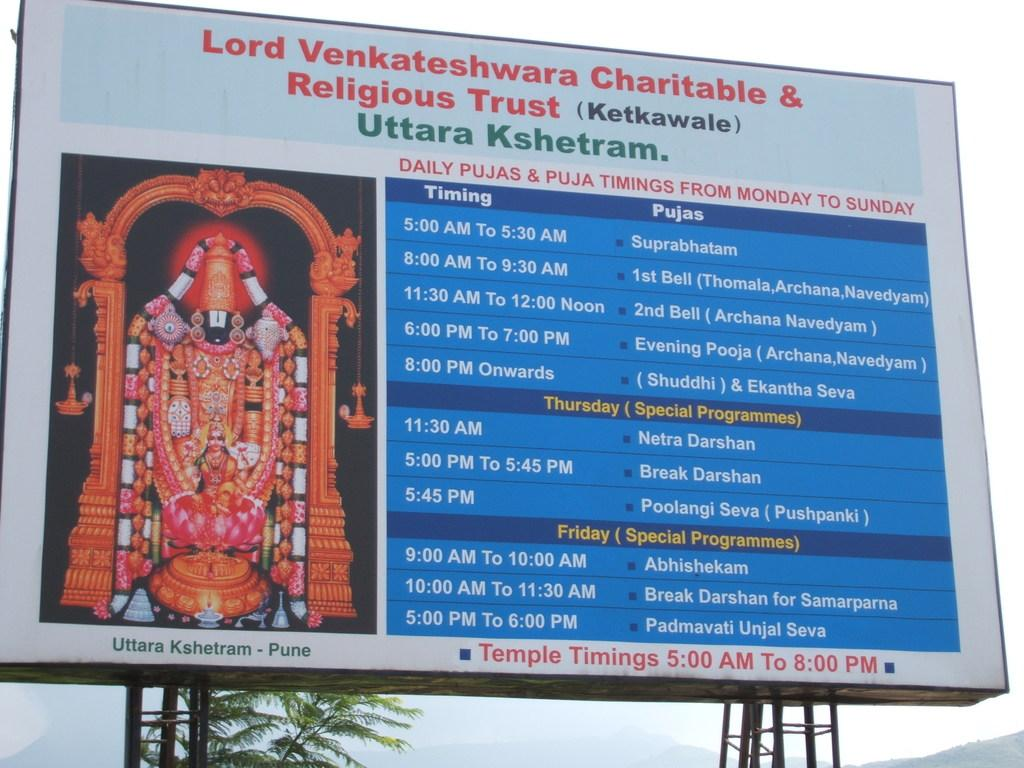<image>
Present a compact description of the photo's key features. a billboard with the word Lord in the top left 